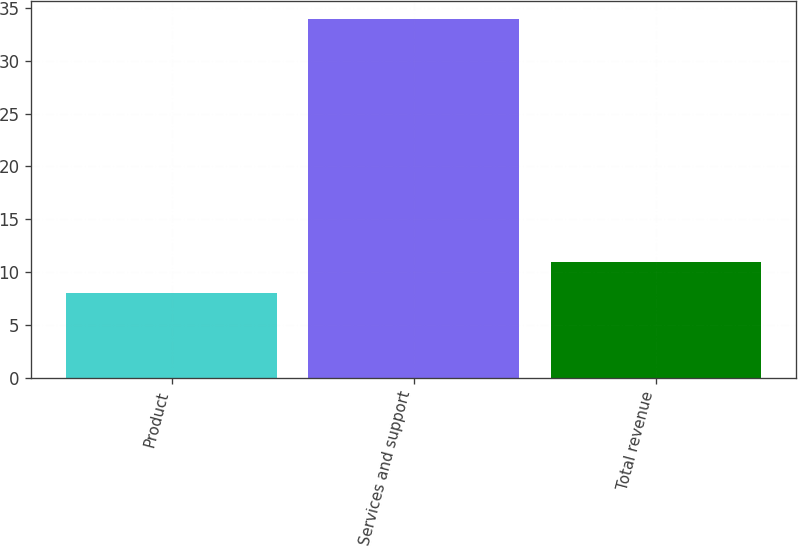<chart> <loc_0><loc_0><loc_500><loc_500><bar_chart><fcel>Product<fcel>Services and support<fcel>Total revenue<nl><fcel>8<fcel>34<fcel>11<nl></chart> 